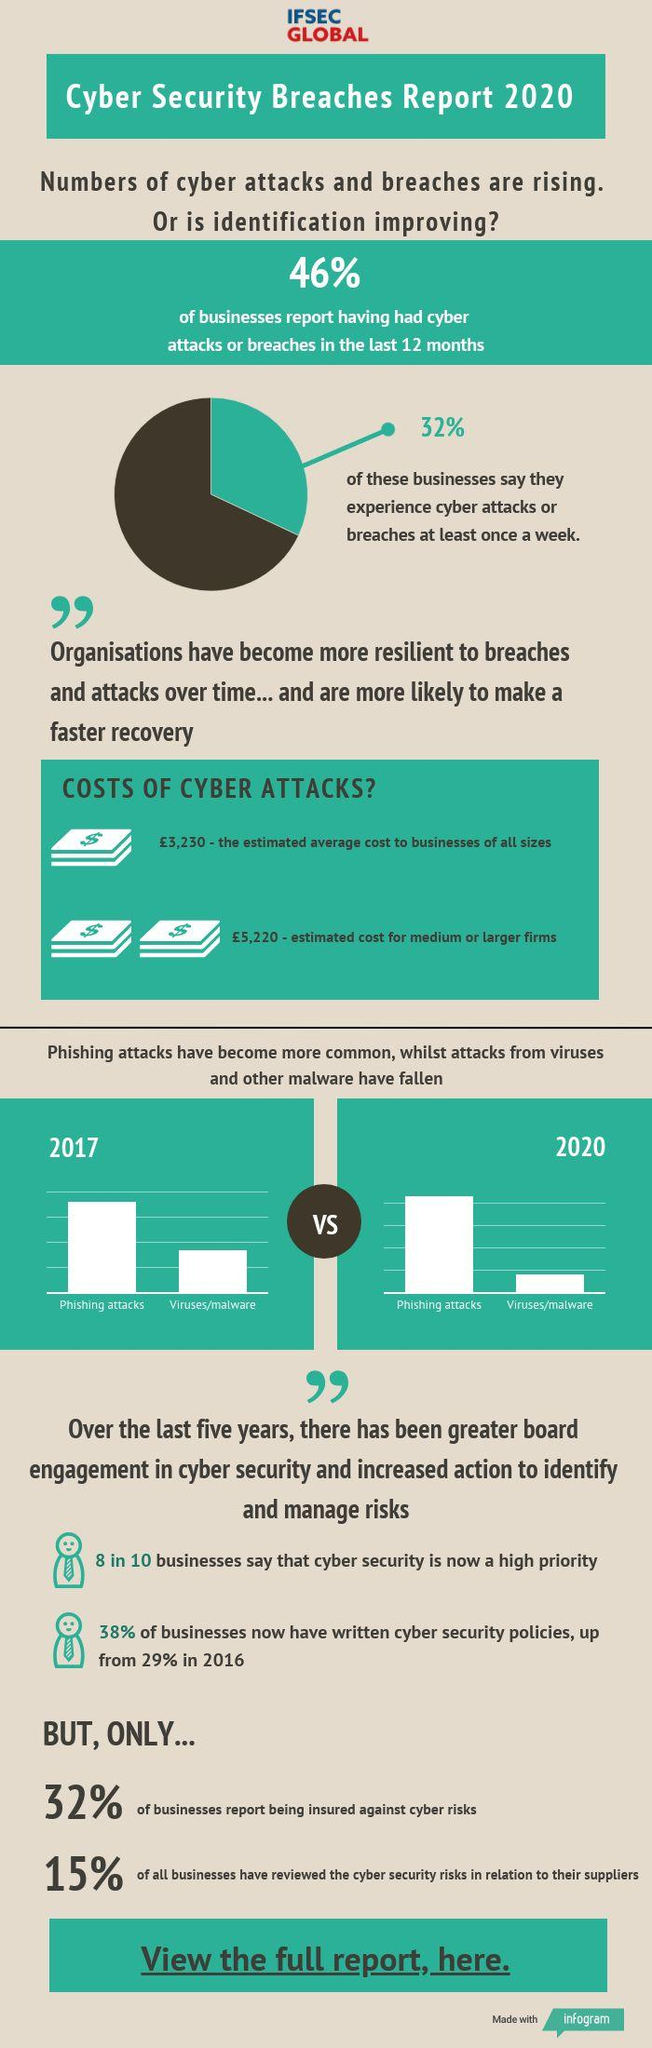Identify some key points in this picture. According to the Cyber Security Breaches Report 2020, 68% of businesses report not being insured against cyber risks. According to the Cyber Security Breaches Report 2020, 68% of businesses reported that they did not experience any cyber attacks or breaches in a week. According to the Cyber Security Breaches Report 2020, 85% of all businesses have not reviewed the cyber security risks in relation to their suppliers. 